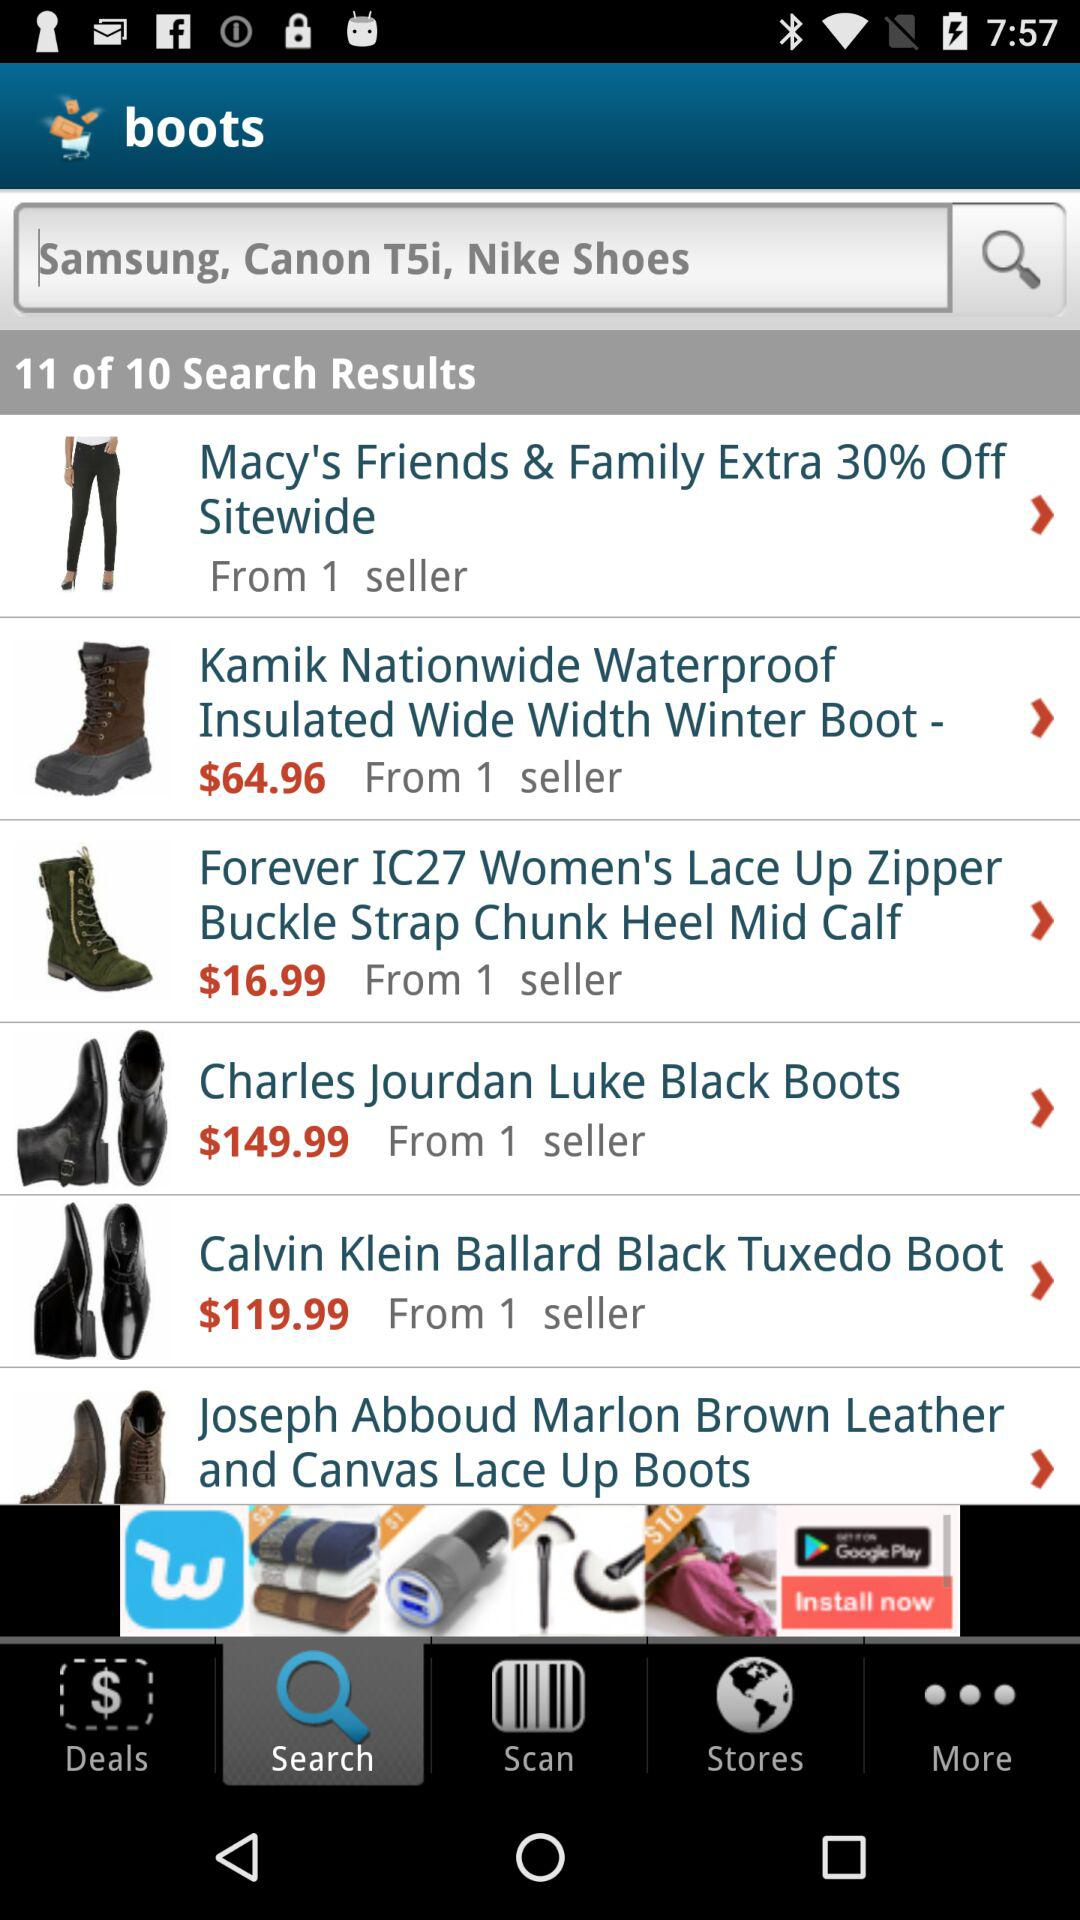What is the price of "Charles Jourdan Luke Black Boots"? The price is $149.99. 